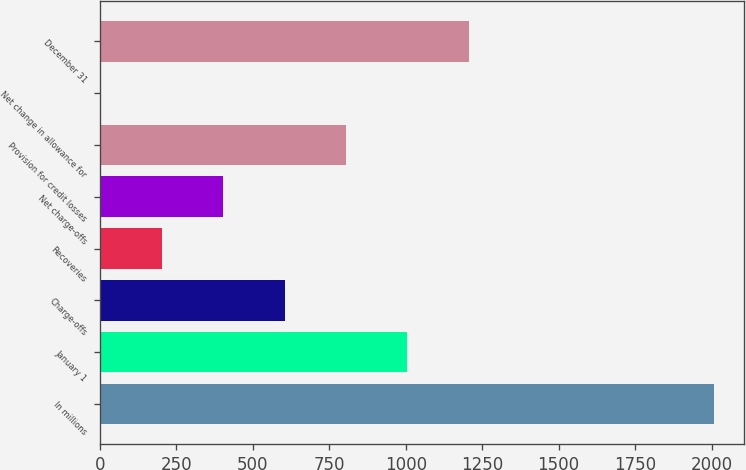Convert chart to OTSL. <chart><loc_0><loc_0><loc_500><loc_500><bar_chart><fcel>In millions<fcel>January 1<fcel>Charge-offs<fcel>Recoveries<fcel>Net charge-offs<fcel>Provision for credit losses<fcel>Net change in allowance for<fcel>December 31<nl><fcel>2007<fcel>1005<fcel>604.2<fcel>203.4<fcel>403.8<fcel>804.6<fcel>3<fcel>1205.4<nl></chart> 